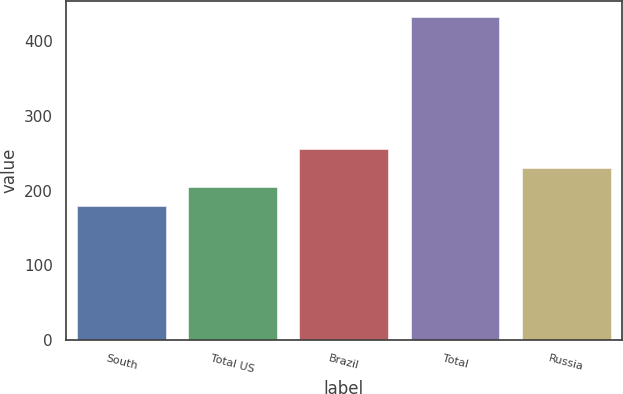<chart> <loc_0><loc_0><loc_500><loc_500><bar_chart><fcel>South<fcel>Total US<fcel>Brazil<fcel>Total<fcel>Russia<nl><fcel>180<fcel>205.2<fcel>255.6<fcel>432<fcel>230.4<nl></chart> 